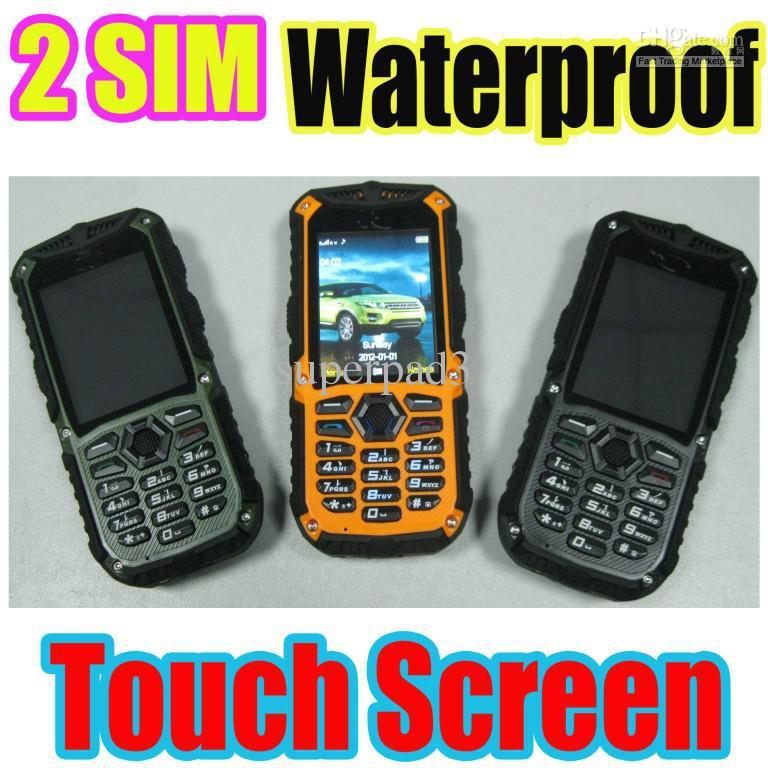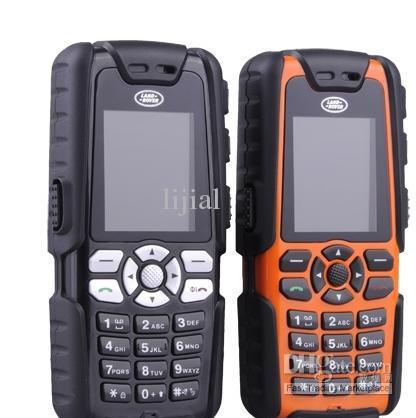The first image is the image on the left, the second image is the image on the right. Analyze the images presented: Is the assertion "The back of a phone is visible." valid? Answer yes or no. No. 